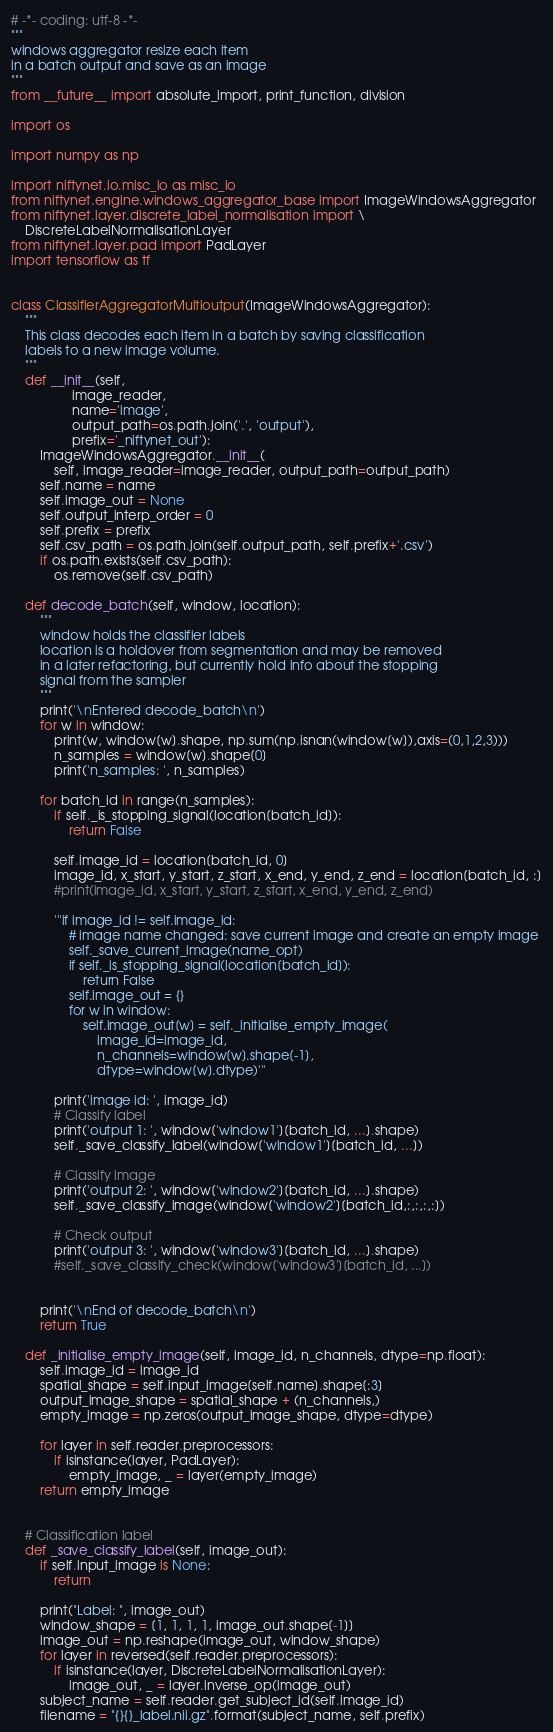<code> <loc_0><loc_0><loc_500><loc_500><_Python_># -*- coding: utf-8 -*-
"""
windows aggregator resize each item
in a batch output and save as an image
"""
from __future__ import absolute_import, print_function, division

import os

import numpy as np

import niftynet.io.misc_io as misc_io
from niftynet.engine.windows_aggregator_base import ImageWindowsAggregator
from niftynet.layer.discrete_label_normalisation import \
    DiscreteLabelNormalisationLayer
from niftynet.layer.pad import PadLayer
import tensorflow as tf


class ClassifierAggregatorMultioutput(ImageWindowsAggregator):
    """
    This class decodes each item in a batch by saving classification
    labels to a new image volume.
    """
    def __init__(self,
                 image_reader,
                 name='image',
                 output_path=os.path.join('.', 'output'),
                 prefix='_niftynet_out'):
        ImageWindowsAggregator.__init__(
            self, image_reader=image_reader, output_path=output_path)
        self.name = name
        self.image_out = None
        self.output_interp_order = 0
        self.prefix = prefix
        self.csv_path = os.path.join(self.output_path, self.prefix+'.csv')
        if os.path.exists(self.csv_path):
            os.remove(self.csv_path)

    def decode_batch(self, window, location):
        """
        window holds the classifier labels
        location is a holdover from segmentation and may be removed
        in a later refactoring, but currently hold info about the stopping
        signal from the sampler
        """
        print('\nEntered decode_batch\n')
        for w in window:
            print(w, window[w].shape, np.sum(np.isnan(window[w]),axis=(0,1,2,3)))
            n_samples = window[w].shape[0]
            print('n_samples: ', n_samples)

        for batch_id in range(n_samples):
            if self._is_stopping_signal(location[batch_id]):
                return False

            self.image_id = location[batch_id, 0]
            image_id, x_start, y_start, z_start, x_end, y_end, z_end = location[batch_id, :]
            #print(image_id, x_start, y_start, z_start, x_end, y_end, z_end)

            '''if image_id != self.image_id:
                # image name changed: save current image and create an empty image
                self._save_current_image(name_opt)
                if self._is_stopping_signal(location[batch_id]):
                    return False
                self.image_out = {}
                for w in window:
                    self.image_out[w] = self._initialise_empty_image(
                        image_id=image_id,
                        n_channels=window[w].shape[-1],
                        dtype=window[w].dtype)'''

            print('image id: ', image_id)
            # Classify label
            print('output 1: ', window['window1'][batch_id, ...].shape)
            self._save_classify_label(window['window1'][batch_id, ...])

            # Classify image
            print('output 2: ', window['window2'][batch_id, ...].shape)
            self._save_classify_image(window['window2'][batch_id,:,:,:,:])

            # Check output
            print('output 3: ', window['window3'][batch_id, ...].shape)
            #self._save_classify_check(window['window3'][batch_id, ...])


        print('\nEnd of decode_batch\n')
        return True

    def _initialise_empty_image(self, image_id, n_channels, dtype=np.float):
        self.image_id = image_id
        spatial_shape = self.input_image[self.name].shape[:3]
        output_image_shape = spatial_shape + (n_channels,)
        empty_image = np.zeros(output_image_shape, dtype=dtype)

        for layer in self.reader.preprocessors:
            if isinstance(layer, PadLayer):
                empty_image, _ = layer(empty_image)
        return empty_image


    # Classification label
    def _save_classify_label(self, image_out):
        if self.input_image is None:
            return

        print("Label: ", image_out)
        window_shape = [1, 1, 1, 1, image_out.shape[-1]]
        image_out = np.reshape(image_out, window_shape)
        for layer in reversed(self.reader.preprocessors):
            if isinstance(layer, DiscreteLabelNormalisationLayer):
                image_out, _ = layer.inverse_op(image_out)
        subject_name = self.reader.get_subject_id(self.image_id)
        filename = "{}{}_label.nii.gz".format(subject_name, self.prefix)</code> 